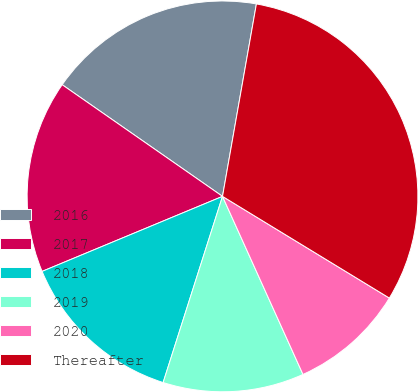<chart> <loc_0><loc_0><loc_500><loc_500><pie_chart><fcel>2016<fcel>2017<fcel>2018<fcel>2019<fcel>2020<fcel>Thereafter<nl><fcel>18.09%<fcel>15.95%<fcel>13.81%<fcel>11.67%<fcel>9.53%<fcel>30.93%<nl></chart> 